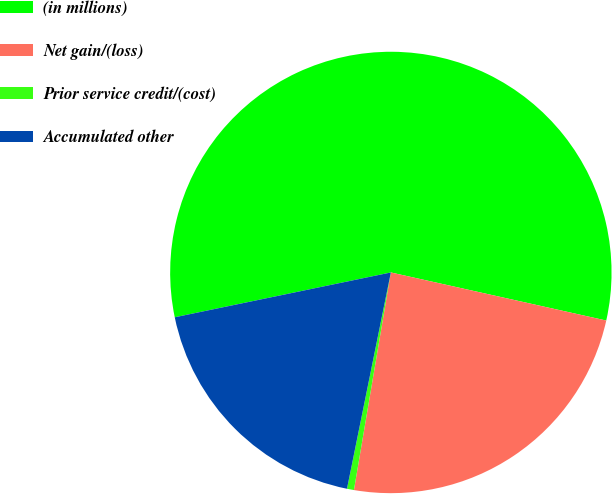Convert chart. <chart><loc_0><loc_0><loc_500><loc_500><pie_chart><fcel>(in millions)<fcel>Net gain/(loss)<fcel>Prior service credit/(cost)<fcel>Accumulated other<nl><fcel>56.75%<fcel>24.18%<fcel>0.51%<fcel>18.56%<nl></chart> 